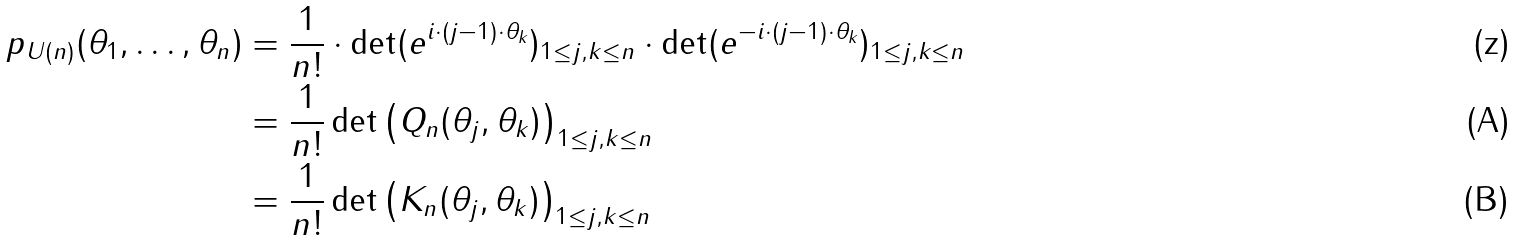<formula> <loc_0><loc_0><loc_500><loc_500>p _ { U ( n ) } ( \theta _ { 1 } , \dots , \theta _ { n } ) & = \frac { 1 } { n ! } \cdot \det ( e ^ { i \cdot ( j - 1 ) \cdot \theta _ { k } } ) _ { 1 \leq j , k \leq n } \cdot \det ( e ^ { - i \cdot ( j - 1 ) \cdot \theta _ { k } } ) _ { 1 \leq j , k \leq n } \\ & = \frac { 1 } { n ! } \det \left ( Q _ { n } ( \theta _ { j } , \theta _ { k } ) \right ) _ { 1 \leq j , k \leq n } \\ & = \frac { 1 } { n ! } \det \left ( K _ { n } ( \theta _ { j } , \theta _ { k } ) \right ) _ { 1 \leq j , k \leq n }</formula> 